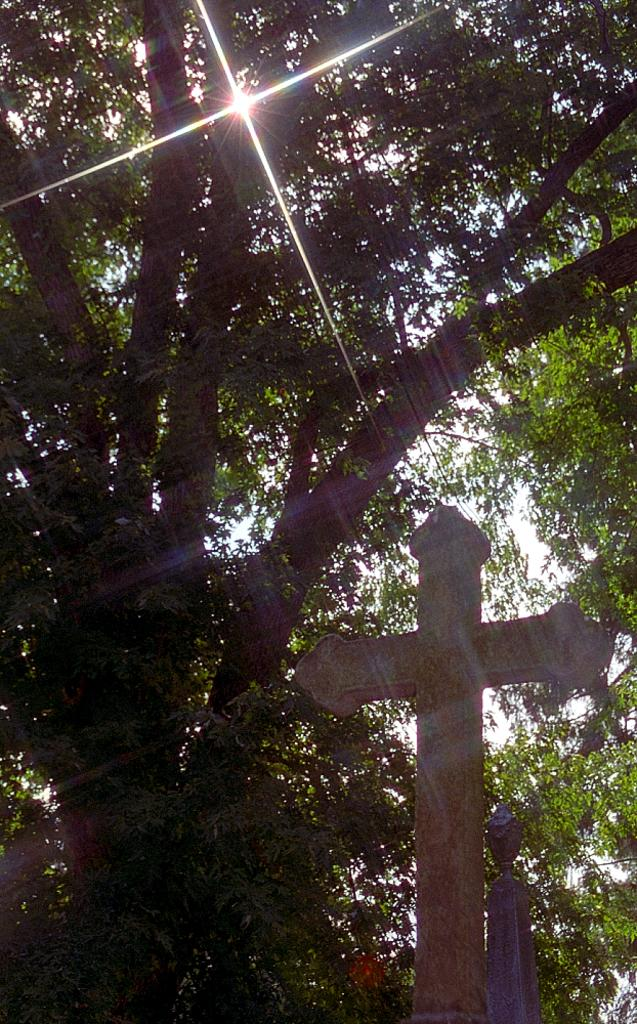What is the main subject in the foreground of the image? There is a cross in the foreground of the image. What can be seen in the background of the image? There are trees and the sky visible in the background of the image. What is the distance between the cross and the gate in the image? There is no gate present in the image, so it is not possible to determine the distance between the cross and a gate. 